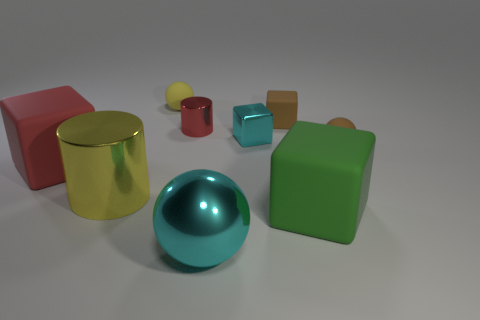What is the size of the metal cube that is the same color as the large ball?
Make the answer very short. Small. There is a large cube right of the large thing that is in front of the big green rubber object; what is its material?
Your answer should be very brief. Rubber. How big is the cylinder behind the small ball that is to the right of the big matte object to the right of the tiny brown cube?
Provide a short and direct response. Small. What number of yellow objects are made of the same material as the tiny brown block?
Provide a succinct answer. 1. What color is the big rubber object that is left of the tiny cube to the left of the brown block?
Your response must be concise. Red. What number of things are yellow metallic cylinders or matte things that are behind the red shiny cylinder?
Provide a succinct answer. 3. Are there any metal things of the same color as the big metallic ball?
Your response must be concise. Yes. How many red things are either tiny metal things or shiny cubes?
Your answer should be very brief. 1. How many other things are there of the same size as the red block?
Your response must be concise. 3. How many large things are either blue balls or red matte blocks?
Make the answer very short. 1. 